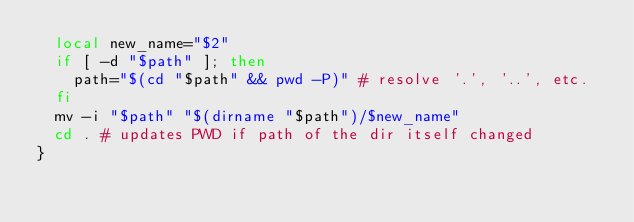Convert code to text. <code><loc_0><loc_0><loc_500><loc_500><_Bash_>	local new_name="$2"
	if [ -d "$path" ]; then
		path="$(cd "$path" && pwd -P)" # resolve '.', '..', etc.
	fi
	mv -i "$path" "$(dirname "$path")/$new_name"
	cd . # updates PWD if path of the dir itself changed
}
</code> 